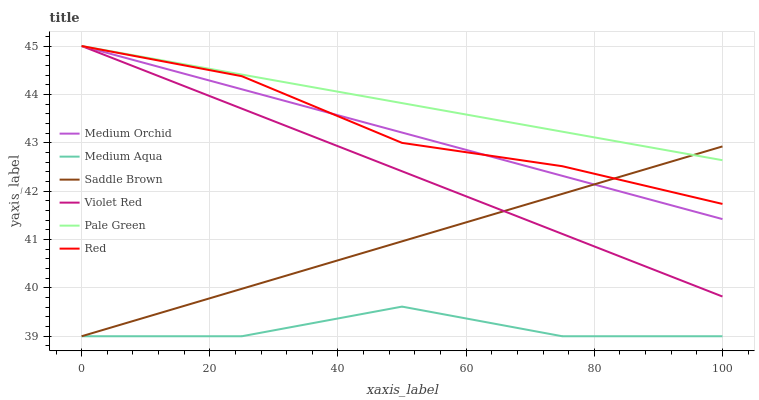Does Medium Orchid have the minimum area under the curve?
Answer yes or no. No. Does Medium Orchid have the maximum area under the curve?
Answer yes or no. No. Is Pale Green the smoothest?
Answer yes or no. No. Is Pale Green the roughest?
Answer yes or no. No. Does Medium Orchid have the lowest value?
Answer yes or no. No. Does Medium Aqua have the highest value?
Answer yes or no. No. Is Medium Aqua less than Red?
Answer yes or no. Yes. Is Red greater than Medium Aqua?
Answer yes or no. Yes. Does Medium Aqua intersect Red?
Answer yes or no. No. 